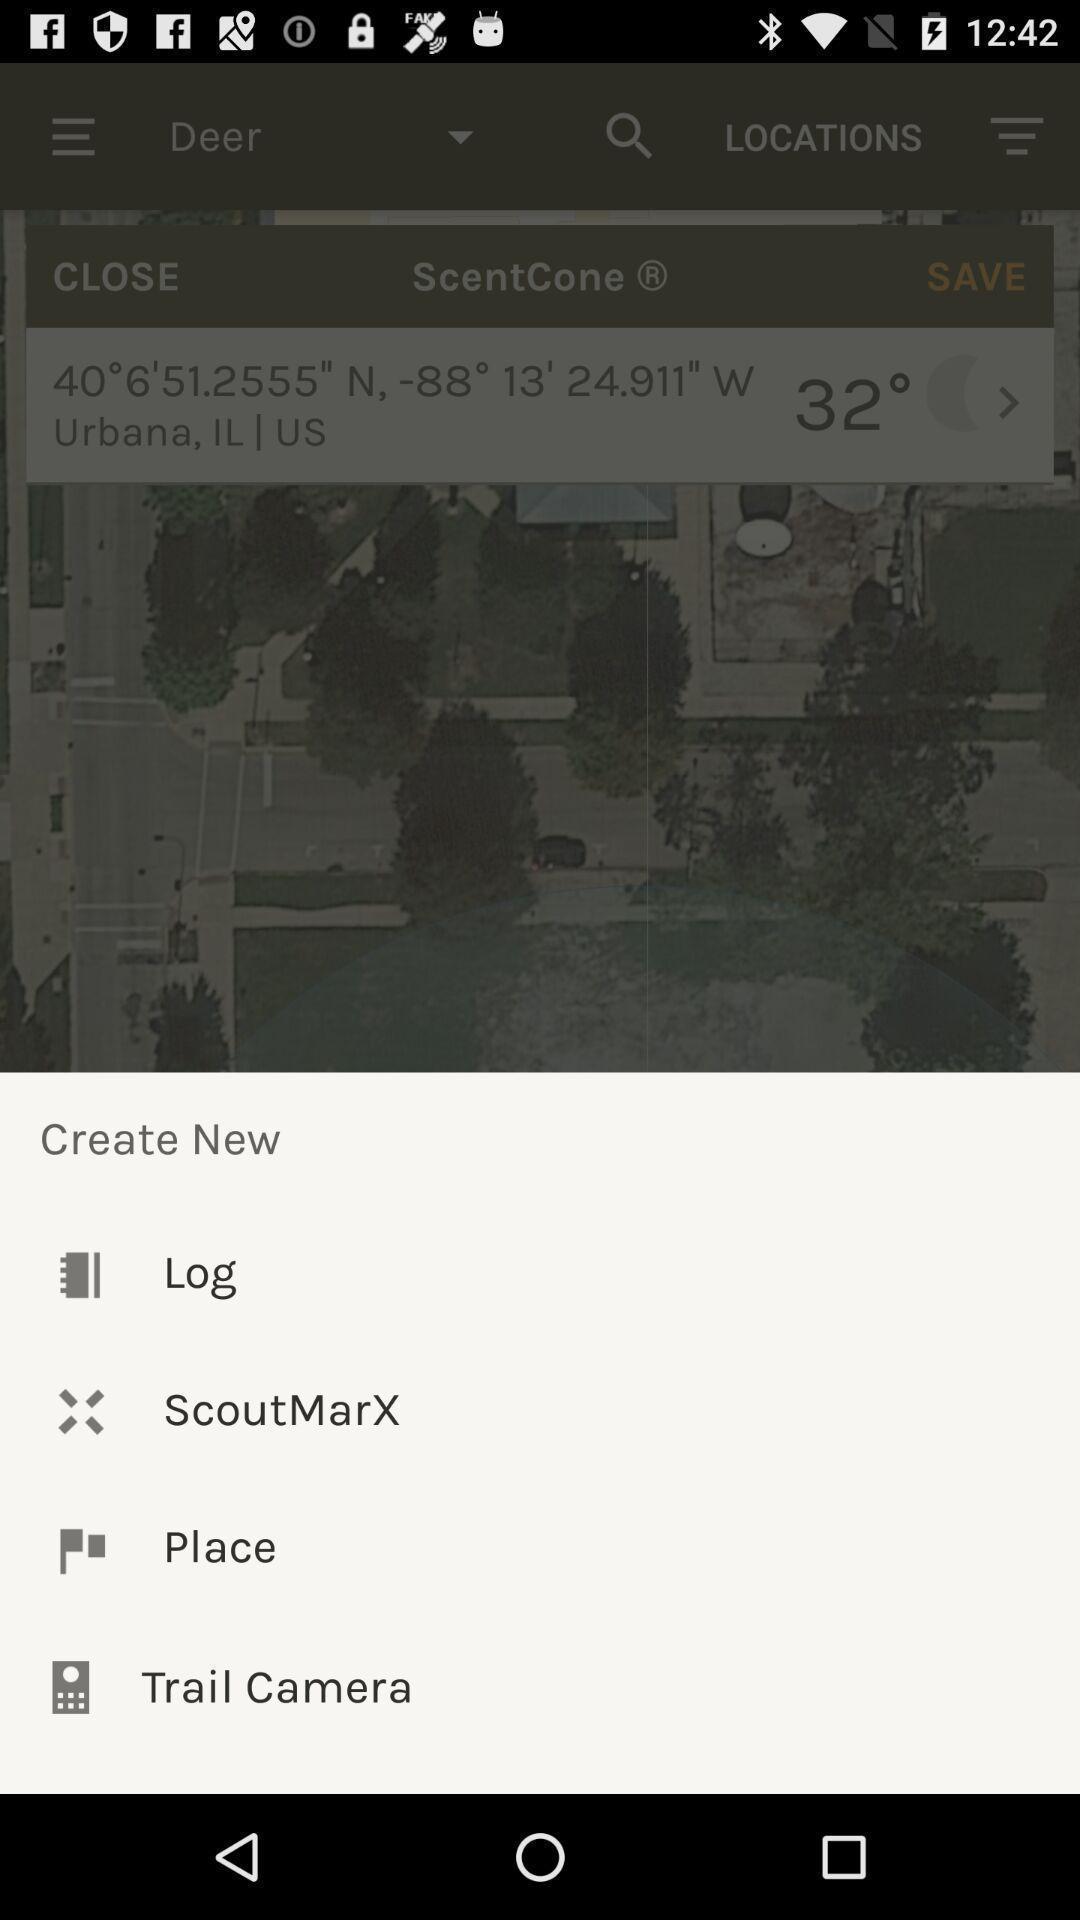Please provide a description for this image. Pop-up displays list of options to create. 